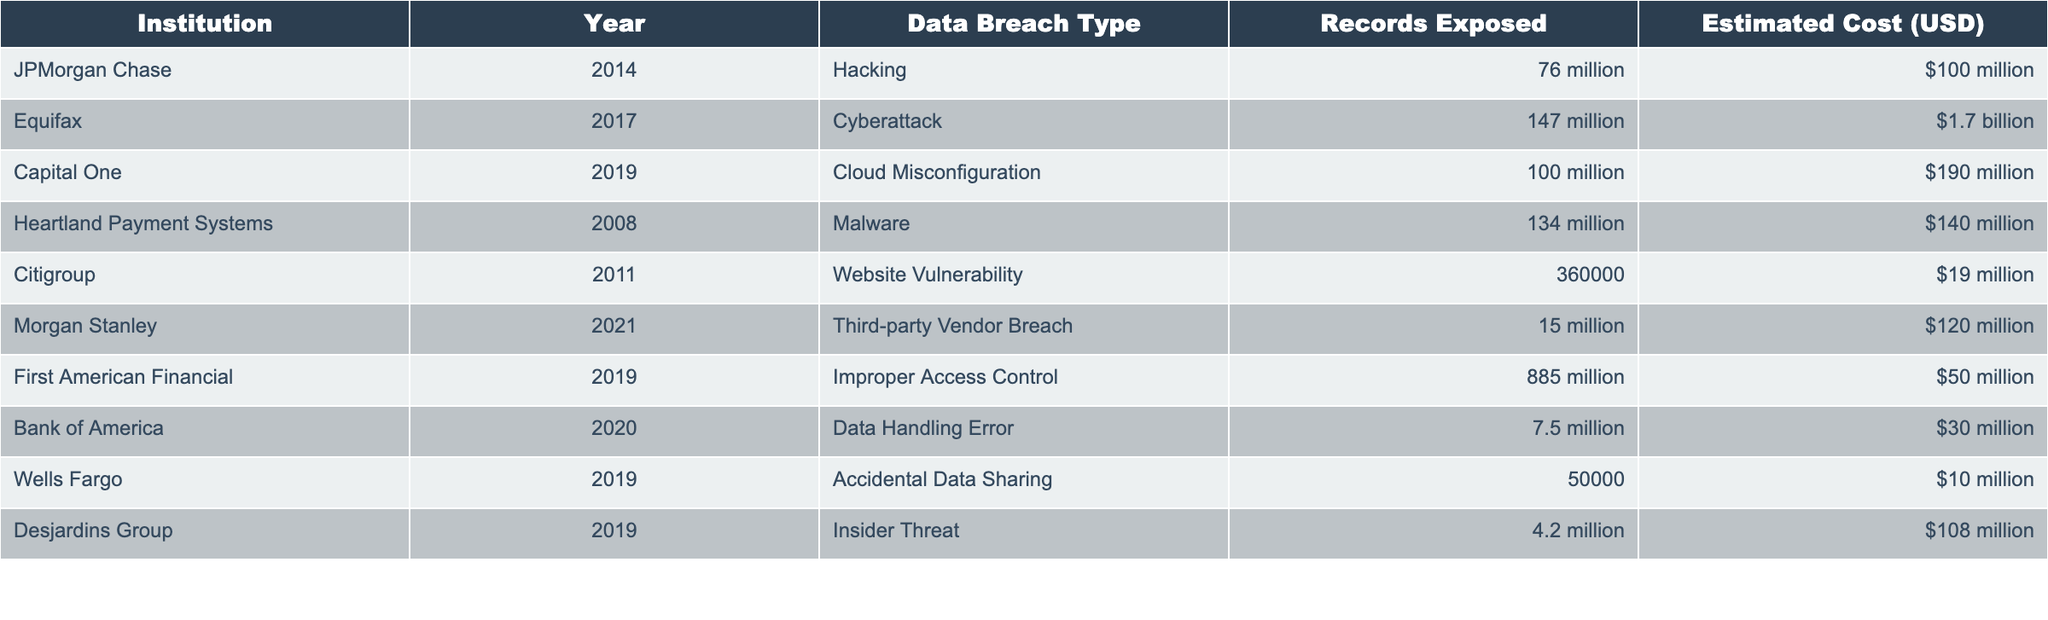What institution experienced the largest data breach in terms of records exposed? First American Financial had the largest number of records exposed with 885 million records in 2019.
Answer: First American Financial What was the estimated cost of the Equifax cyberattack in 2017? The table shows that the estimated cost of the Equifax cyberattack in 2017 was $1.7 billion.
Answer: $1.7 billion How many instances of data breaches resulted in costs greater than $100 million? Looking at the estimated costs, Equifax ($1.7 billion), JPMorgan Chase ($100 million), and Capital One ($190 million) exceed $100 million, totaling three instances.
Answer: 3 Is it true that all breaches listed involved over 1 million records being exposed? No, Citigroup in 2011 had a data breach with only 360,000 records exposed, which is less than 1 million.
Answer: No What is the average estimated cost of all data breaches listed in the table? To calculate the average, first sum the estimated costs: $100 million + $1.7 billion + $190 million + $140 million + $19 million + $120 million + $50 million + $30 million + $10 million + $108 million = $2.4 billion. There are 10 entries, so divide 2.4 billion by 10 to get an average of $240 million.
Answer: $240 million What is the least costly data breach incident in this table? The least costly incident is Wells Fargo in 2019 with an estimated cost of $10 million.
Answer: $10 million How many institutions suffered a data breach in 2019? Examining the table, Capital One, First American Financial, and Wells Fargo all reported data breaches in 2019, totaling three institutions.
Answer: 3 What was the difference in estimated costs between the highest and lowest data breach incident? The highest cost is $1.7 billion (Equifax) and the lowest is $10 million (Wells Fargo). The difference is $1.7 billion - $10 million = $1.69 billion.
Answer: $1.69 billion 